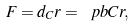Convert formula to latex. <formula><loc_0><loc_0><loc_500><loc_500>F = d _ { C } r = \ p b { C } { r } ,</formula> 